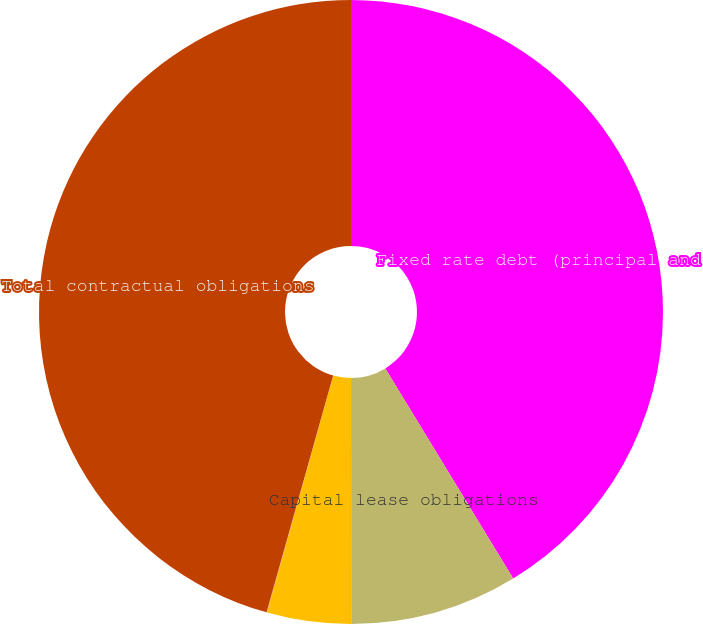<chart> <loc_0><loc_0><loc_500><loc_500><pie_chart><fcel>Fixed rate debt (principal and<fcel>Capital lease obligations<fcel>Operating leases<fcel>Contractual operating<fcel>Total contractual obligations<nl><fcel>41.3%<fcel>8.69%<fcel>4.35%<fcel>0.02%<fcel>45.64%<nl></chart> 